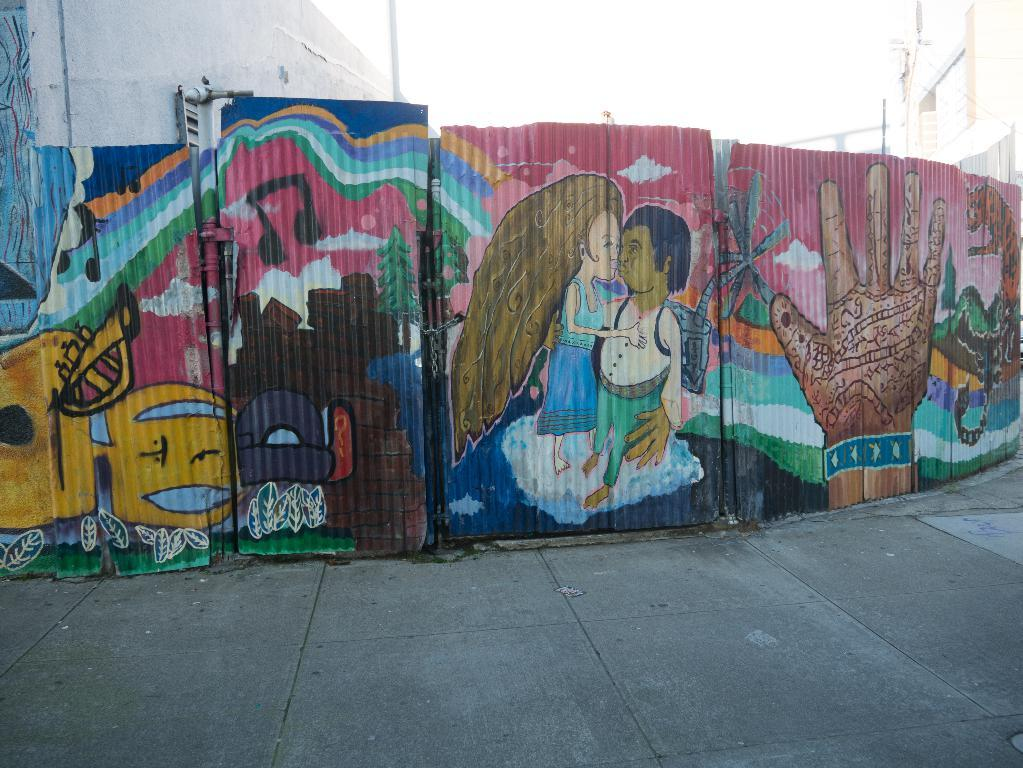What is depicted on the wall in the image? The wall has a painting of people's hands and other cartoons in the painting. What else can be seen in the background of the image? There are poles and the sky visible in the background of the image. How does the ice affect the painting on the wall in the image? There is no ice present in the image, so it cannot affect the painting on the wall. What type of division can be seen between the poles in the image? There is no division between the poles mentioned in the image; they are simply visible in the background. 